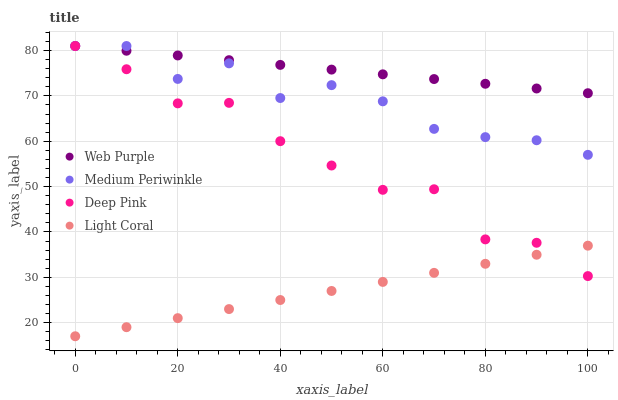Does Light Coral have the minimum area under the curve?
Answer yes or no. Yes. Does Web Purple have the maximum area under the curve?
Answer yes or no. Yes. Does Deep Pink have the minimum area under the curve?
Answer yes or no. No. Does Deep Pink have the maximum area under the curve?
Answer yes or no. No. Is Light Coral the smoothest?
Answer yes or no. Yes. Is Medium Periwinkle the roughest?
Answer yes or no. Yes. Is Web Purple the smoothest?
Answer yes or no. No. Is Web Purple the roughest?
Answer yes or no. No. Does Light Coral have the lowest value?
Answer yes or no. Yes. Does Deep Pink have the lowest value?
Answer yes or no. No. Does Medium Periwinkle have the highest value?
Answer yes or no. Yes. Is Light Coral less than Medium Periwinkle?
Answer yes or no. Yes. Is Medium Periwinkle greater than Light Coral?
Answer yes or no. Yes. Does Medium Periwinkle intersect Web Purple?
Answer yes or no. Yes. Is Medium Periwinkle less than Web Purple?
Answer yes or no. No. Is Medium Periwinkle greater than Web Purple?
Answer yes or no. No. Does Light Coral intersect Medium Periwinkle?
Answer yes or no. No. 